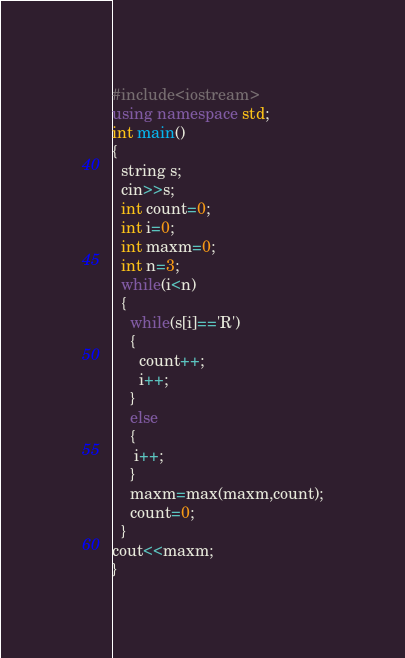Convert code to text. <code><loc_0><loc_0><loc_500><loc_500><_C++_>#include<iostream>
using namespace std;
int main()
{
  string s;
  cin>>s;
  int count=0;
  int i=0;
  int maxm=0;
  int n=3;
  while(i<n)
  {
    while(s[i]=='R')
    {
      count++;
      i++;
    }
    else
    {
     i++; 
    }
    maxm=max(maxm,count);
    count=0;
  }
cout<<maxm;
}
</code> 